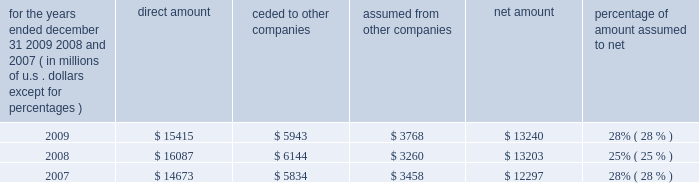S c h e d u l e i v ace limited and subsidiaries s u p p l e m e n t a l i n f o r m a t i o n c o n c e r n i n g r e i n s u r a n c e premiums earned for the years ended december 31 , 2009 , 2008 , and 2007 ( in millions of u.s .
Dollars , except for percentages ) direct amount ceded to companies assumed from other companies net amount percentage of amount assumed to .

What percent of the direct amount is assumed from other companies in 2009 , ( in millions ) ? 
Computations: (3768 / 15415)
Answer: 0.24444. 